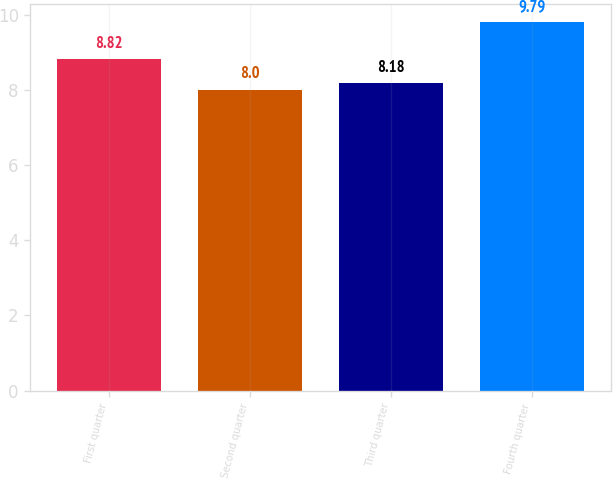Convert chart. <chart><loc_0><loc_0><loc_500><loc_500><bar_chart><fcel>First quarter<fcel>Second quarter<fcel>Third quarter<fcel>Fourth quarter<nl><fcel>8.82<fcel>8<fcel>8.18<fcel>9.79<nl></chart> 